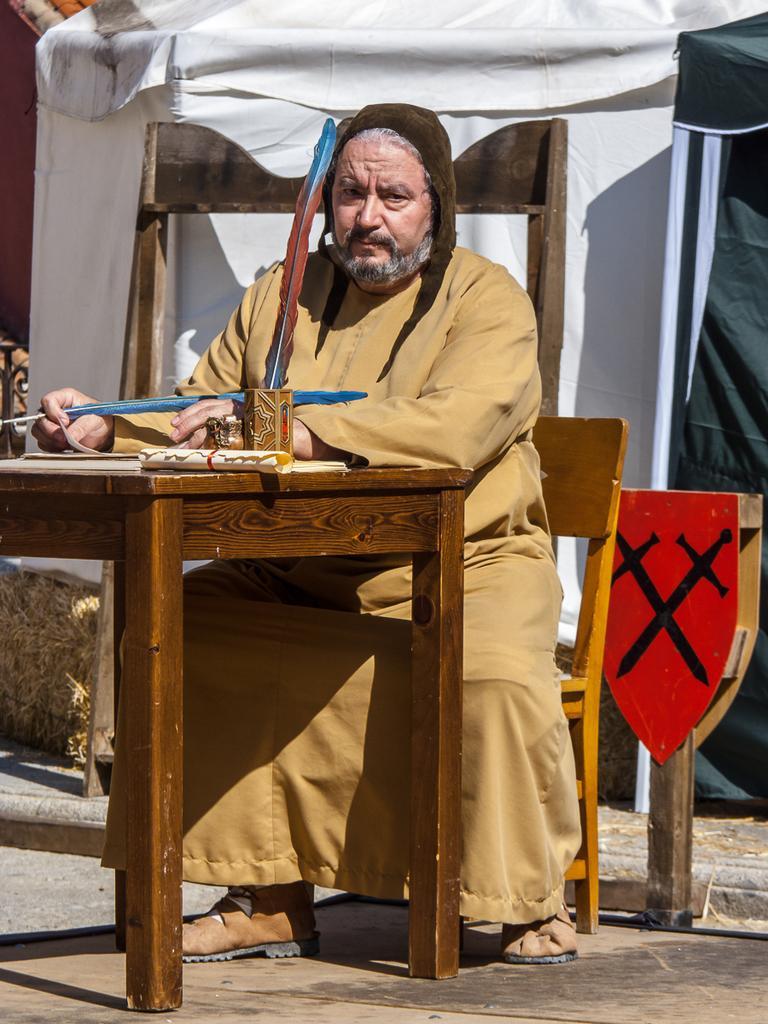Could you give a brief overview of what you see in this image? In this image there is a person sitting on the chair and holding a small stick, there is a table on the table there are a rolled paper, a bowl with a stick in it and some other objects, there are few tents. 